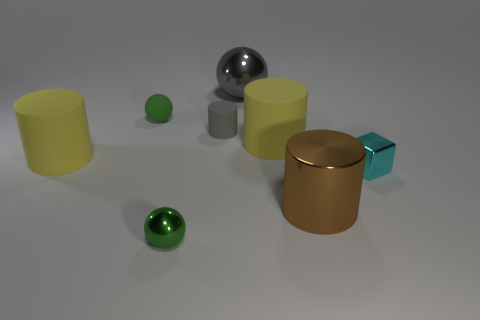Is the number of tiny spheres behind the tiny matte cylinder the same as the number of large rubber cylinders?
Offer a very short reply. No. Are there any other things that have the same material as the small cube?
Give a very brief answer. Yes. Is the color of the metallic ball that is on the right side of the tiny gray matte object the same as the tiny ball behind the large brown metal object?
Offer a terse response. No. What number of shiny objects are both left of the cyan thing and to the right of the gray shiny sphere?
Give a very brief answer. 1. How many other objects are there of the same shape as the small cyan shiny thing?
Your answer should be very brief. 0. Are there more rubber objects on the left side of the large ball than big gray metal things?
Make the answer very short. Yes. The shiny ball in front of the big gray metal object is what color?
Your answer should be very brief. Green. The thing that is the same color as the small cylinder is what size?
Make the answer very short. Large. What number of rubber things are small cyan things or yellow objects?
Provide a short and direct response. 2. There is a yellow object right of the thing behind the green rubber object; is there a large metallic cylinder to the left of it?
Your response must be concise. No. 